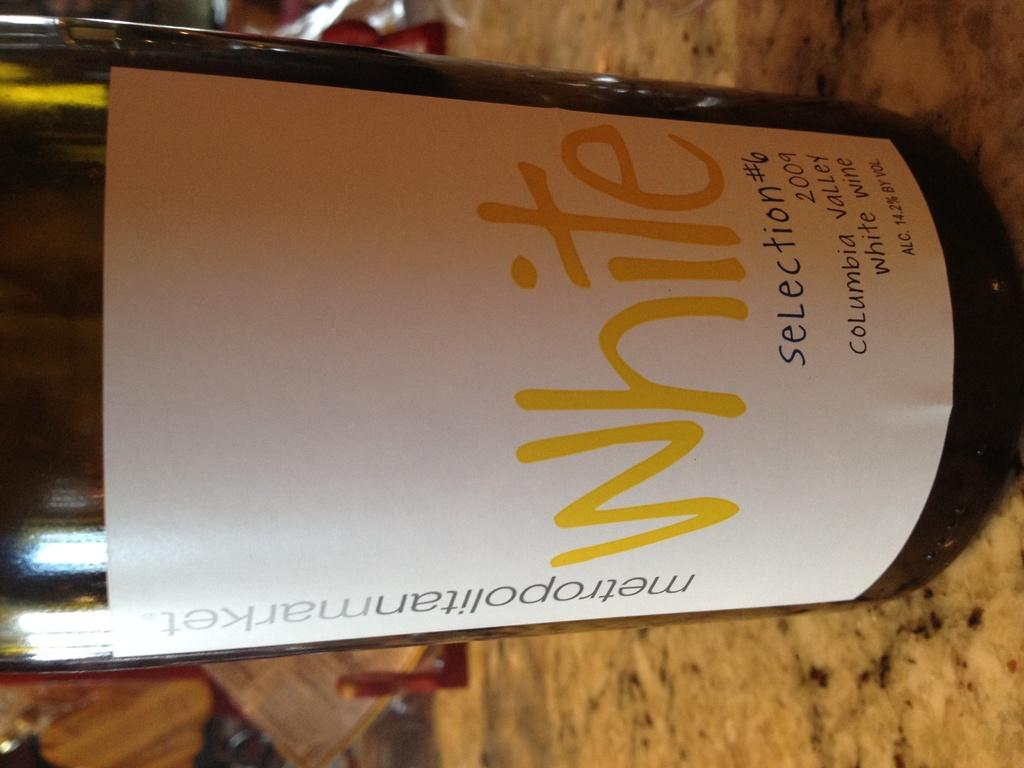What object can be seen in the image? There is a bottle in the image. What is written or printed on the bottle? There is text on the bottle. What type of zinc object can be seen in the image? There is no zinc object present in the image. What kind of marble surface is visible in the image? There is no marble surface visible in the image. 